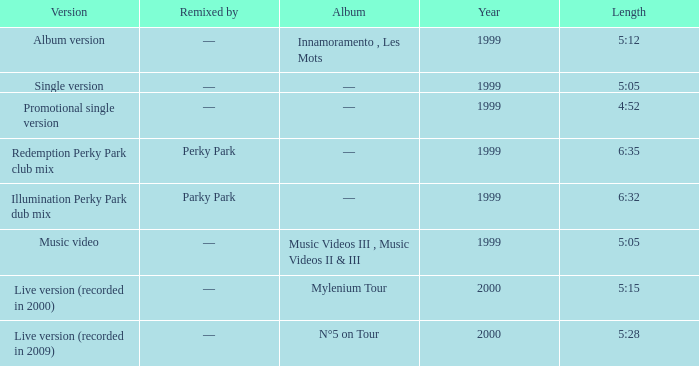What album is 5:15 long Live version (recorded in 2000). 